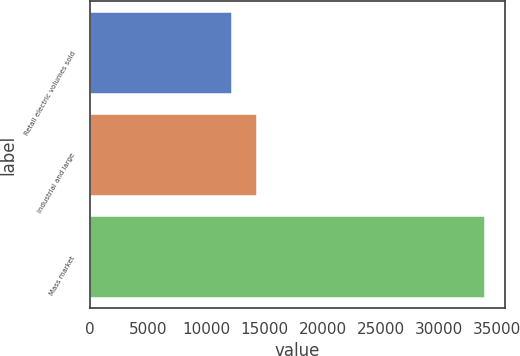Convert chart to OTSL. <chart><loc_0><loc_0><loc_500><loc_500><bar_chart><fcel>Retail electric volumes sold<fcel>Industrial and large<fcel>Mass market<nl><fcel>12209<fcel>14386<fcel>33979<nl></chart> 